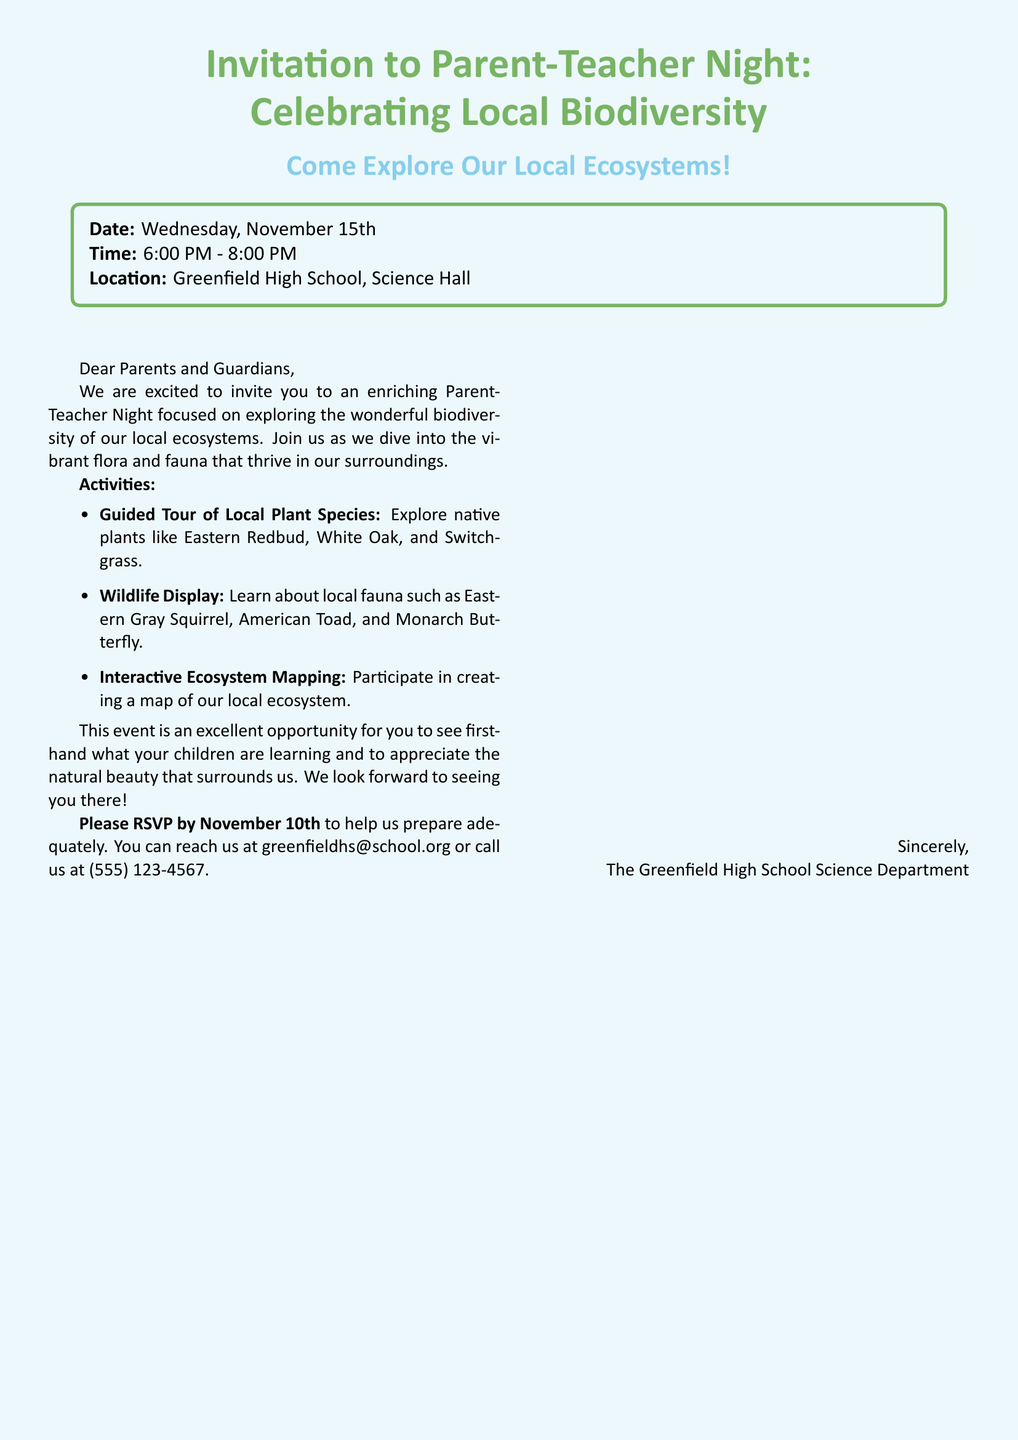What is the date of the event? The date of the event is explicitly mentioned in the document as "Wednesday, November 15th."
Answer: Wednesday, November 15th What time does the event start? The event start time is listed in the document as "6:00 PM - 8:00 PM."
Answer: 6:00 PM Where will the event take place? The document specifies the location as "Greenfield High School, Science Hall."
Answer: Greenfield High School, Science Hall What is one of the guided tour topics? The document lists "Guided Tour of Local Plant Species" as an activity, focusing on native plants.
Answer: Native plants What is one local fauna mentioned? The document includes "Eastern Gray Squirrel" as an example of local fauna featured in the event.
Answer: Eastern Gray Squirrel What is the RSVP deadline? The RSVP deadline is clearly stated in the document as "November 10th."
Answer: November 10th What type of activities are mentioned? The document outlines activities including a guided tour, wildlife display, and interactive mapping.
Answer: Activities What is the purpose of the Parent-Teacher Night? The document mentions that the event is focused on "exploring the wonderful biodiversity of our local ecosystems."
Answer: Exploring local biodiversity 